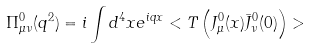Convert formula to latex. <formula><loc_0><loc_0><loc_500><loc_500>\Pi _ { \mu \nu } ^ { 0 } ( q ^ { 2 } ) = i \int d ^ { 4 } x e ^ { i q x } < T \left ( J _ { \mu } ^ { 0 } ( x ) \bar { J } _ { \nu } ^ { 0 } ( 0 ) \right ) ></formula> 